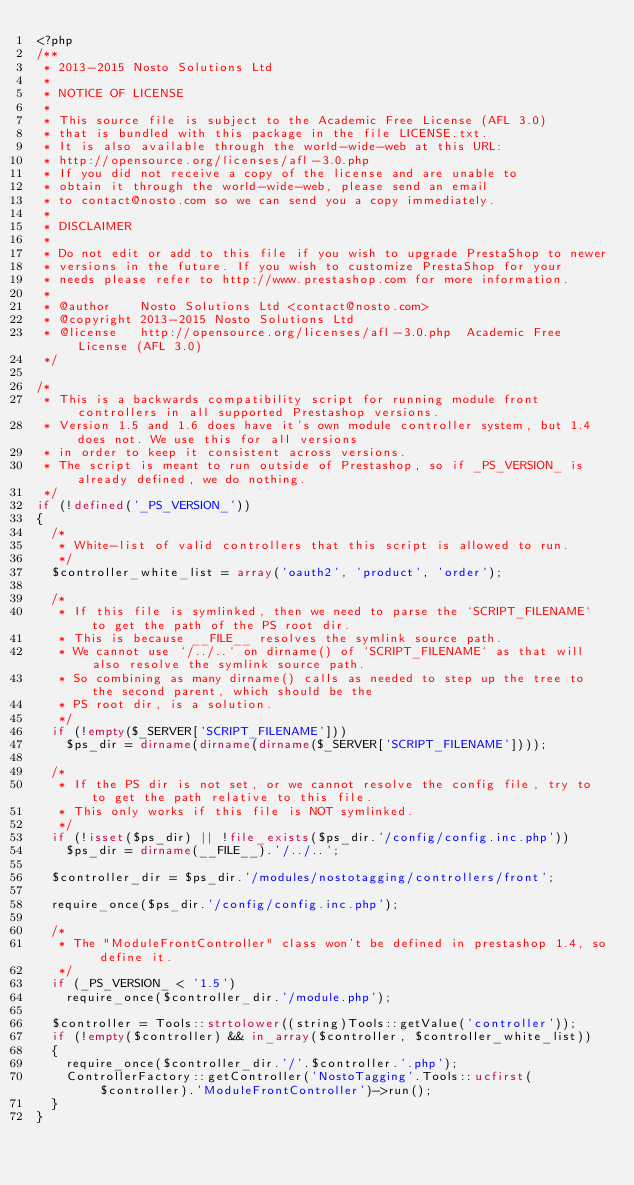Convert code to text. <code><loc_0><loc_0><loc_500><loc_500><_PHP_><?php
/**
 * 2013-2015 Nosto Solutions Ltd
 *
 * NOTICE OF LICENSE
 *
 * This source file is subject to the Academic Free License (AFL 3.0)
 * that is bundled with this package in the file LICENSE.txt.
 * It is also available through the world-wide-web at this URL:
 * http://opensource.org/licenses/afl-3.0.php
 * If you did not receive a copy of the license and are unable to
 * obtain it through the world-wide-web, please send an email
 * to contact@nosto.com so we can send you a copy immediately.
 *
 * DISCLAIMER
 *
 * Do not edit or add to this file if you wish to upgrade PrestaShop to newer
 * versions in the future. If you wish to customize PrestaShop for your
 * needs please refer to http://www.prestashop.com for more information.
 *
 * @author    Nosto Solutions Ltd <contact@nosto.com>
 * @copyright 2013-2015 Nosto Solutions Ltd
 * @license   http://opensource.org/licenses/afl-3.0.php  Academic Free License (AFL 3.0)
 */

/*
 * This is a backwards compatibility script for running module front controllers in all supported Prestashop versions.
 * Version 1.5 and 1.6 does have it's own module controller system, but 1.4 does not. We use this for all versions
 * in order to keep it consistent across versions.
 * The script is meant to run outside of Prestashop, so if _PS_VERSION_ is already defined, we do nothing.
 */
if (!defined('_PS_VERSION_'))
{
	/*
	 * White-list of valid controllers that this script is allowed to run.
	 */
	$controller_white_list = array('oauth2', 'product', 'order');

	/*
	 * If this file is symlinked, then we need to parse the `SCRIPT_FILENAME` to get the path of the PS root dir.
	 * This is because __FILE__ resolves the symlink source path.
	 * We cannot use `/../..` on dirname() of `SCRIPT_FILENAME` as that will also resolve the symlink source path.
	 * So combining as many dirname() calls as needed to step up the tree to the second parent, which should be the
	 * PS root dir, is a solution.
	 */
	if (!empty($_SERVER['SCRIPT_FILENAME']))
		$ps_dir = dirname(dirname(dirname($_SERVER['SCRIPT_FILENAME'])));

	/*
	 * If the PS dir is not set, or we cannot resolve the config file, try to to get the path relative to this file.
	 * This only works if this file is NOT symlinked.
	 */
	if (!isset($ps_dir) || !file_exists($ps_dir.'/config/config.inc.php'))
		$ps_dir = dirname(__FILE__).'/../..';

	$controller_dir = $ps_dir.'/modules/nostotagging/controllers/front';

	require_once($ps_dir.'/config/config.inc.php');

	/*
	 * The "ModuleFrontController" class won't be defined in prestashop 1.4, so define it.
	 */
	if (_PS_VERSION_ < '1.5')
		require_once($controller_dir.'/module.php');

	$controller = Tools::strtolower((string)Tools::getValue('controller'));
	if (!empty($controller) && in_array($controller, $controller_white_list))
	{
		require_once($controller_dir.'/'.$controller.'.php');
		ControllerFactory::getController('NostoTagging'.Tools::ucfirst($controller).'ModuleFrontController')->run();
	}
}
</code> 